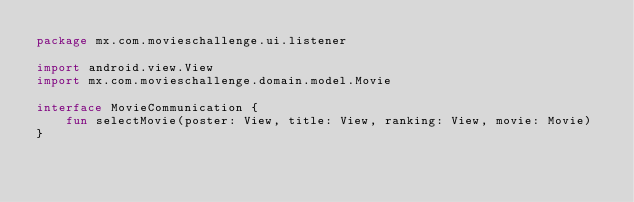Convert code to text. <code><loc_0><loc_0><loc_500><loc_500><_Kotlin_>package mx.com.movieschallenge.ui.listener

import android.view.View
import mx.com.movieschallenge.domain.model.Movie

interface MovieCommunication {
    fun selectMovie(poster: View, title: View, ranking: View, movie: Movie)
}</code> 